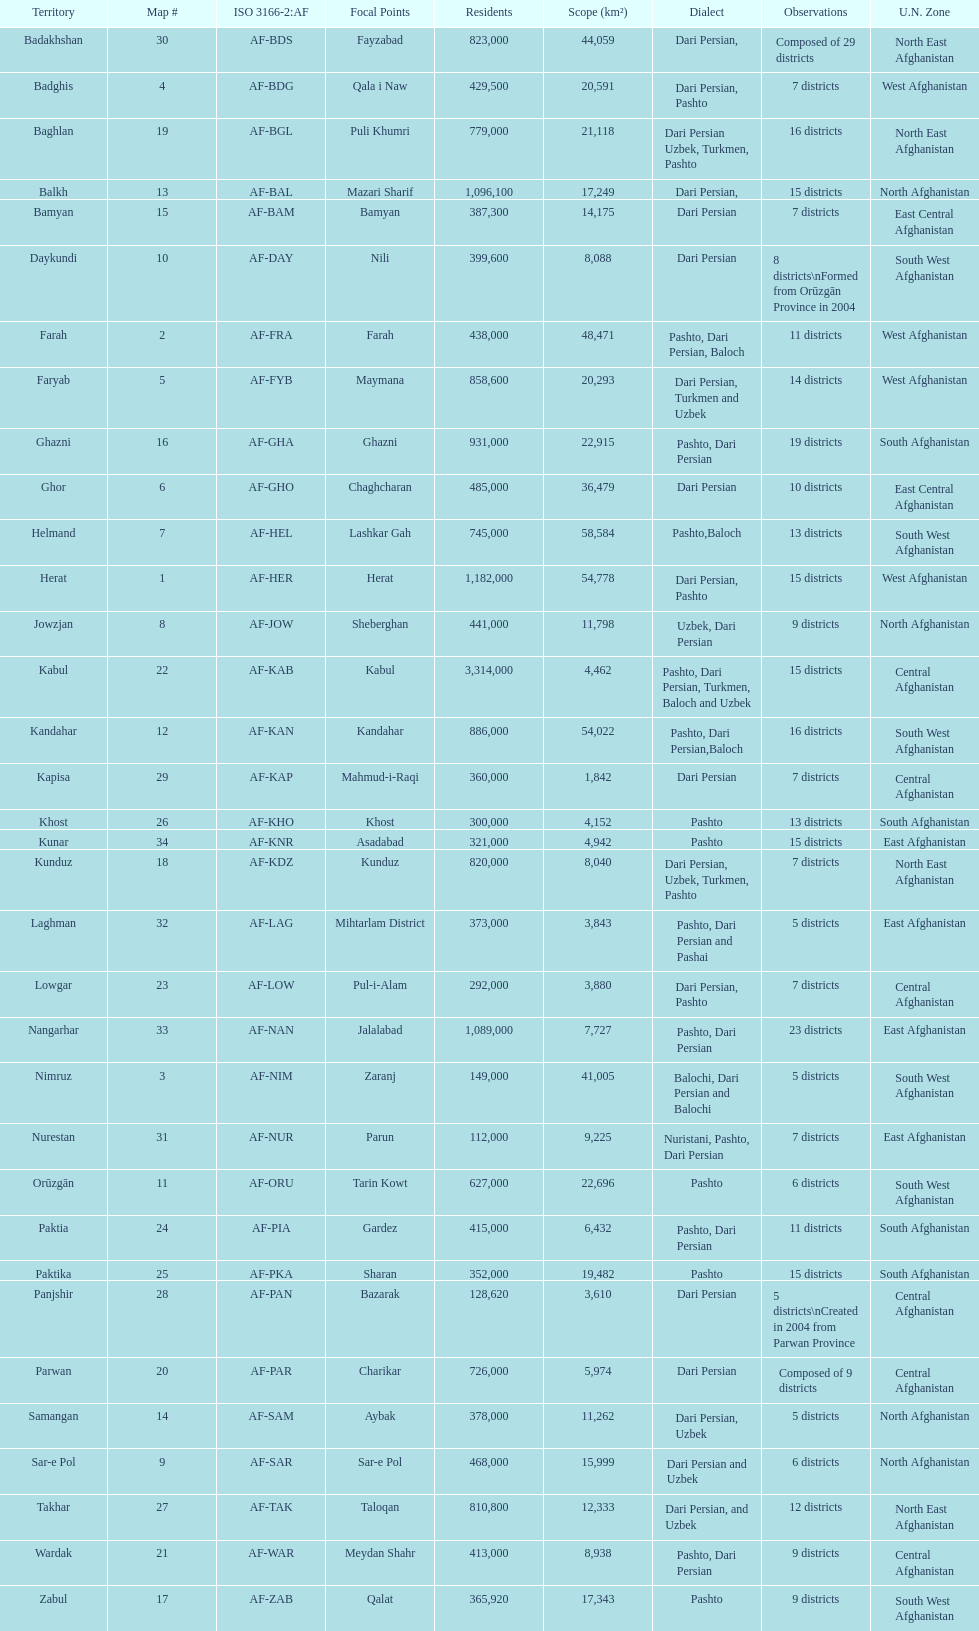How many provinces have the same number of districts as kabul? 4. 